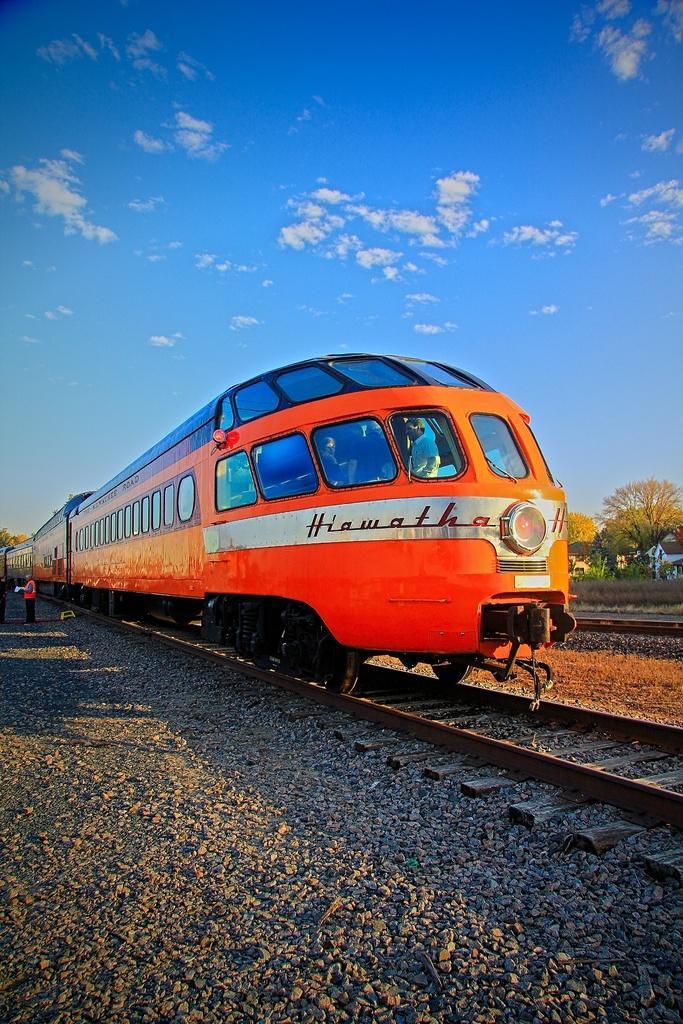How would you summarize this image in a sentence or two? There is a train with windows and something written on that. And is on a railway track. In the back there are stones. On the right side there are trees. In the background there is sky with clouds. Inside the train there are some people. On the left side there is a person standing. 